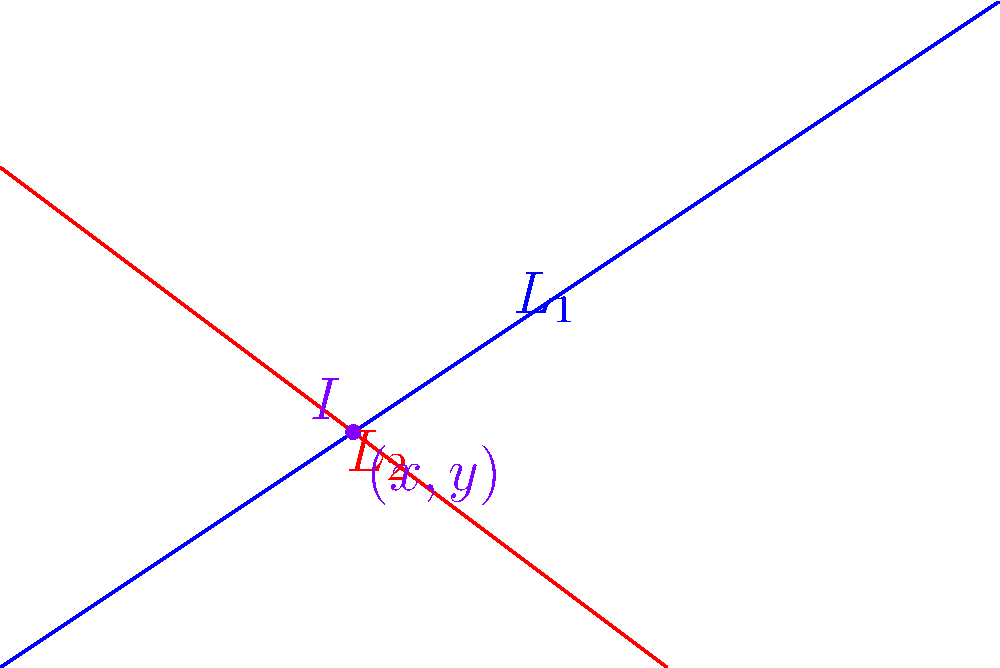In your t-shirt design process, you're working on a geometric pattern involving two intersecting lines. Line $L_1$ passes through points (0,0) and (6,4), while line $L_2$ passes through (0,3) and (4,0). Find the coordinates of the intersection point $I$ of these two lines. How could you use this intersection point to create a unique focal point in your t-shirt design? Let's solve this step-by-step:

1) First, we need to find the equations of both lines.

2) For line $L_1$:
   Slope $m_1 = \frac{4-0}{6-0} = \frac{2}{3}$
   Using point-slope form: $y - 0 = \frac{2}{3}(x - 0)$
   Equation of $L_1$: $y = \frac{2}{3}x$

3) For line $L_2$:
   Slope $m_2 = \frac{0-3}{4-0} = -\frac{3}{4}$
   Using point-slope form: $y - 3 = -\frac{3}{4}(x - 0)$
   Equation of $L_2$: $y = -\frac{3}{4}x + 3$

4) At the intersection point, the x and y coordinates will be the same for both lines. So we can equate the two y expressions:

   $\frac{2}{3}x = -\frac{3}{4}x + 3$

5) Solve for x:
   $\frac{2}{3}x + \frac{3}{4}x = 3$
   $\frac{8}{12}x + \frac{9}{12}x = 3$
   $\frac{17}{12}x = 3$
   $x = \frac{36}{17} = 2.12$

6) Substitute this x value into either line equation to find y:
   $y = \frac{2}{3}(2.12) = 1.41$

7) Therefore, the intersection point $I$ is approximately (2.12, 1.41).

In t-shirt design, this intersection point could be used as a focal point for a geometric pattern. You could emphasize this point by placing a design element there, or use it as the center for a radial pattern. The precise coordinates add a mathematical touch to your design process.
Answer: $I \approx (2.12, 1.41)$ 